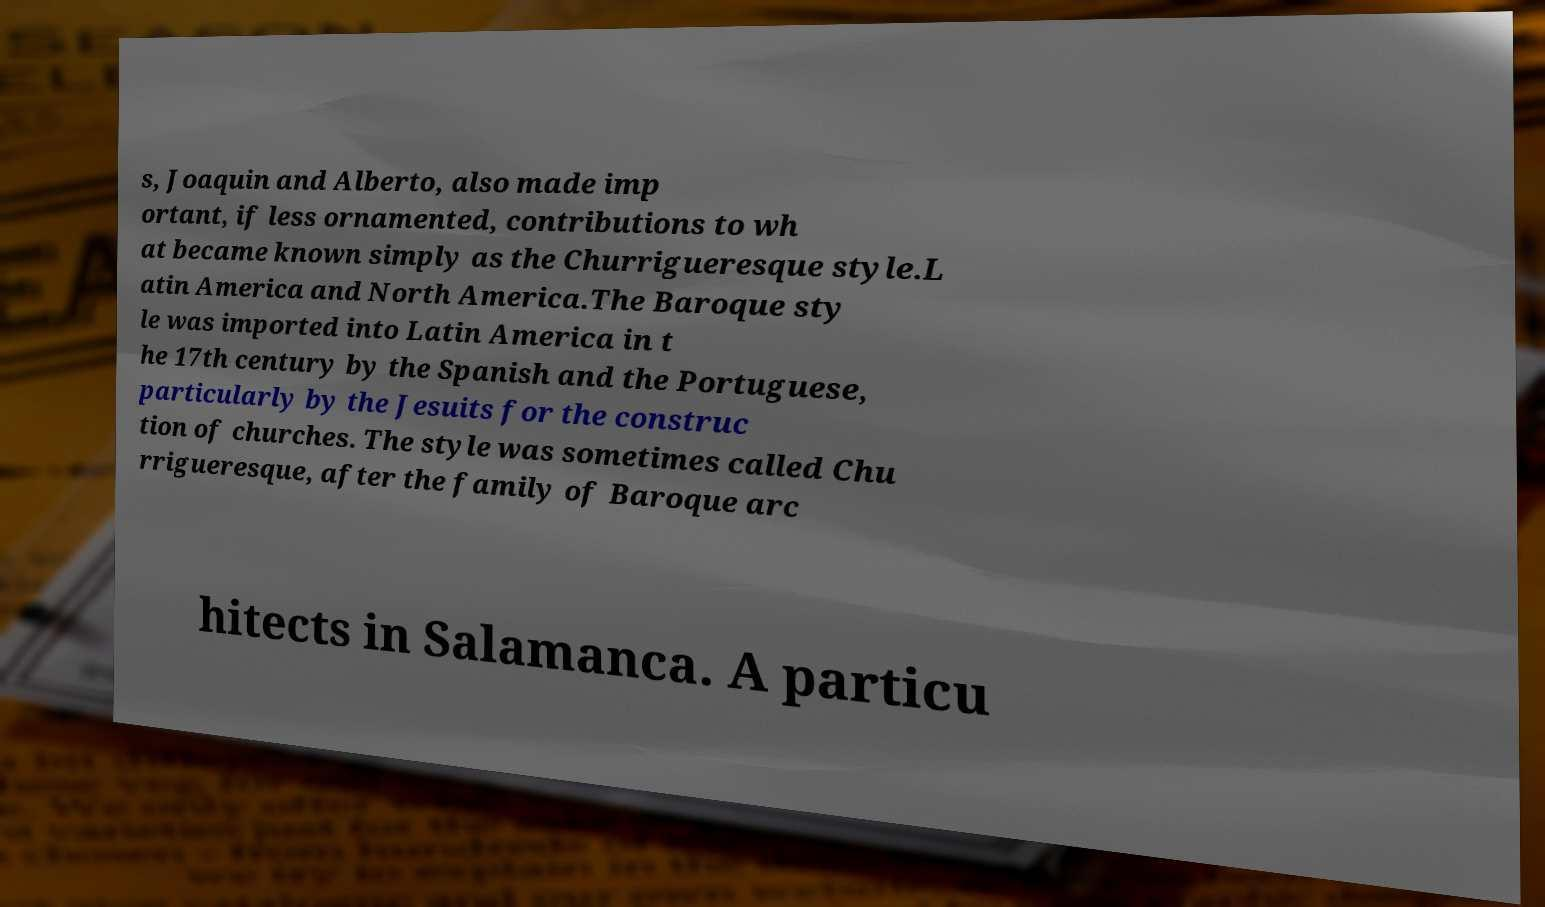I need the written content from this picture converted into text. Can you do that? s, Joaquin and Alberto, also made imp ortant, if less ornamented, contributions to wh at became known simply as the Churrigueresque style.L atin America and North America.The Baroque sty le was imported into Latin America in t he 17th century by the Spanish and the Portuguese, particularly by the Jesuits for the construc tion of churches. The style was sometimes called Chu rrigueresque, after the family of Baroque arc hitects in Salamanca. A particu 